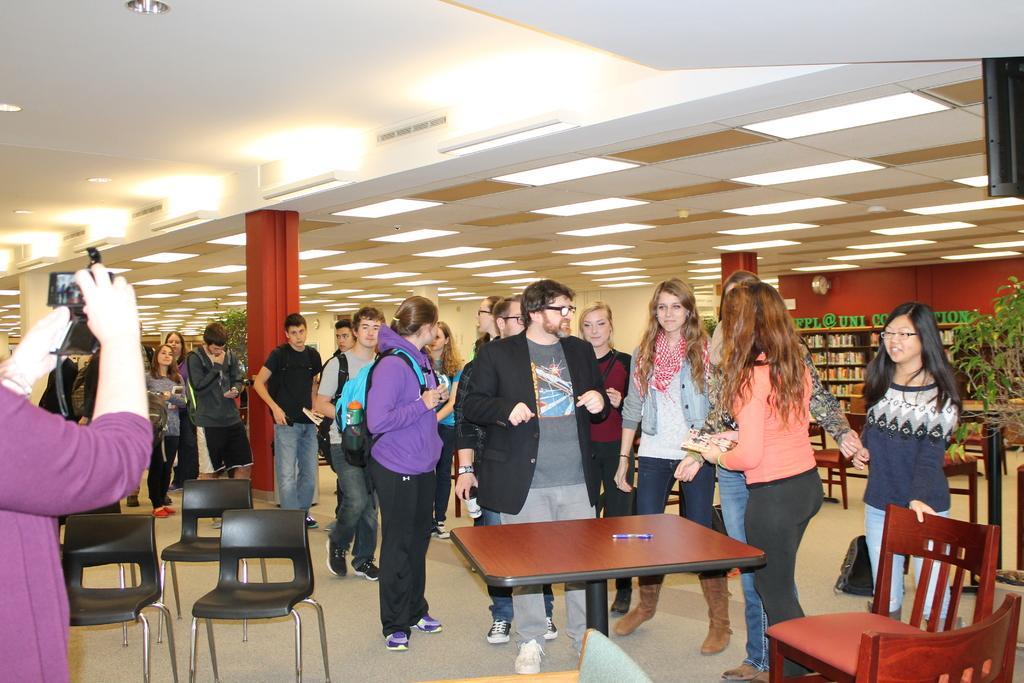Please provide a concise description of this image. There are several people standing in this picture and photographs are clicking the pictures of a guy who is wearing a black coat. There are few unoccupied chairs over here. To the roof there are LED lights fitted. 